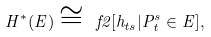<formula> <loc_0><loc_0><loc_500><loc_500>H ^ { * } ( E ) \cong \ f 2 [ h _ { t s } | P ^ { s } _ { t } \in E ] ,</formula> 